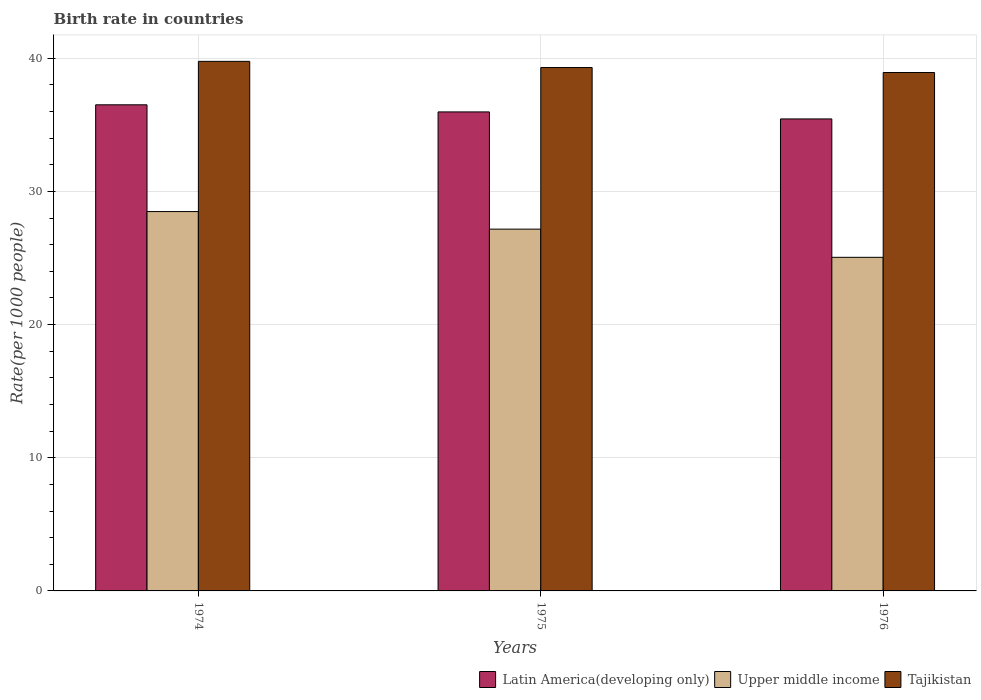How many groups of bars are there?
Provide a succinct answer. 3. Are the number of bars per tick equal to the number of legend labels?
Give a very brief answer. Yes. How many bars are there on the 3rd tick from the right?
Offer a terse response. 3. What is the label of the 1st group of bars from the left?
Your answer should be very brief. 1974. What is the birth rate in Upper middle income in 1976?
Give a very brief answer. 25.05. Across all years, what is the maximum birth rate in Upper middle income?
Make the answer very short. 28.49. Across all years, what is the minimum birth rate in Latin America(developing only)?
Make the answer very short. 35.45. In which year was the birth rate in Latin America(developing only) maximum?
Keep it short and to the point. 1974. In which year was the birth rate in Tajikistan minimum?
Offer a terse response. 1976. What is the total birth rate in Upper middle income in the graph?
Keep it short and to the point. 80.71. What is the difference between the birth rate in Latin America(developing only) in 1975 and that in 1976?
Offer a terse response. 0.53. What is the difference between the birth rate in Latin America(developing only) in 1975 and the birth rate in Upper middle income in 1974?
Your response must be concise. 7.48. What is the average birth rate in Tajikistan per year?
Keep it short and to the point. 39.34. In the year 1974, what is the difference between the birth rate in Tajikistan and birth rate in Upper middle income?
Your response must be concise. 11.28. What is the ratio of the birth rate in Upper middle income in 1975 to that in 1976?
Offer a very short reply. 1.08. Is the birth rate in Latin America(developing only) in 1974 less than that in 1975?
Offer a very short reply. No. Is the difference between the birth rate in Tajikistan in 1975 and 1976 greater than the difference between the birth rate in Upper middle income in 1975 and 1976?
Your response must be concise. No. What is the difference between the highest and the second highest birth rate in Latin America(developing only)?
Make the answer very short. 0.53. What is the difference between the highest and the lowest birth rate in Tajikistan?
Your response must be concise. 0.84. Is the sum of the birth rate in Upper middle income in 1974 and 1976 greater than the maximum birth rate in Tajikistan across all years?
Offer a very short reply. Yes. What does the 2nd bar from the left in 1976 represents?
Your answer should be compact. Upper middle income. What does the 2nd bar from the right in 1975 represents?
Provide a short and direct response. Upper middle income. Is it the case that in every year, the sum of the birth rate in Latin America(developing only) and birth rate in Upper middle income is greater than the birth rate in Tajikistan?
Give a very brief answer. Yes. How many bars are there?
Your response must be concise. 9. Are all the bars in the graph horizontal?
Give a very brief answer. No. How many years are there in the graph?
Make the answer very short. 3. Does the graph contain grids?
Give a very brief answer. Yes. How many legend labels are there?
Keep it short and to the point. 3. How are the legend labels stacked?
Offer a very short reply. Horizontal. What is the title of the graph?
Provide a short and direct response. Birth rate in countries. What is the label or title of the Y-axis?
Make the answer very short. Rate(per 1000 people). What is the Rate(per 1000 people) in Latin America(developing only) in 1974?
Your response must be concise. 36.51. What is the Rate(per 1000 people) of Upper middle income in 1974?
Offer a very short reply. 28.49. What is the Rate(per 1000 people) in Tajikistan in 1974?
Provide a succinct answer. 39.77. What is the Rate(per 1000 people) in Latin America(developing only) in 1975?
Offer a very short reply. 35.97. What is the Rate(per 1000 people) of Upper middle income in 1975?
Offer a terse response. 27.17. What is the Rate(per 1000 people) in Tajikistan in 1975?
Your response must be concise. 39.3. What is the Rate(per 1000 people) in Latin America(developing only) in 1976?
Ensure brevity in your answer.  35.45. What is the Rate(per 1000 people) of Upper middle income in 1976?
Offer a very short reply. 25.05. What is the Rate(per 1000 people) in Tajikistan in 1976?
Offer a terse response. 38.93. Across all years, what is the maximum Rate(per 1000 people) in Latin America(developing only)?
Make the answer very short. 36.51. Across all years, what is the maximum Rate(per 1000 people) of Upper middle income?
Give a very brief answer. 28.49. Across all years, what is the maximum Rate(per 1000 people) in Tajikistan?
Offer a very short reply. 39.77. Across all years, what is the minimum Rate(per 1000 people) of Latin America(developing only)?
Your answer should be compact. 35.45. Across all years, what is the minimum Rate(per 1000 people) in Upper middle income?
Provide a succinct answer. 25.05. Across all years, what is the minimum Rate(per 1000 people) of Tajikistan?
Give a very brief answer. 38.93. What is the total Rate(per 1000 people) of Latin America(developing only) in the graph?
Give a very brief answer. 107.93. What is the total Rate(per 1000 people) of Upper middle income in the graph?
Provide a succinct answer. 80.71. What is the total Rate(per 1000 people) in Tajikistan in the graph?
Your answer should be very brief. 118.01. What is the difference between the Rate(per 1000 people) of Latin America(developing only) in 1974 and that in 1975?
Provide a succinct answer. 0.53. What is the difference between the Rate(per 1000 people) of Upper middle income in 1974 and that in 1975?
Offer a terse response. 1.32. What is the difference between the Rate(per 1000 people) in Tajikistan in 1974 and that in 1975?
Your response must be concise. 0.47. What is the difference between the Rate(per 1000 people) in Latin America(developing only) in 1974 and that in 1976?
Keep it short and to the point. 1.06. What is the difference between the Rate(per 1000 people) of Upper middle income in 1974 and that in 1976?
Offer a terse response. 3.44. What is the difference between the Rate(per 1000 people) in Tajikistan in 1974 and that in 1976?
Keep it short and to the point. 0.84. What is the difference between the Rate(per 1000 people) in Latin America(developing only) in 1975 and that in 1976?
Provide a succinct answer. 0.53. What is the difference between the Rate(per 1000 people) of Upper middle income in 1975 and that in 1976?
Offer a terse response. 2.12. What is the difference between the Rate(per 1000 people) in Tajikistan in 1975 and that in 1976?
Your answer should be very brief. 0.37. What is the difference between the Rate(per 1000 people) in Latin America(developing only) in 1974 and the Rate(per 1000 people) in Upper middle income in 1975?
Provide a short and direct response. 9.34. What is the difference between the Rate(per 1000 people) of Latin America(developing only) in 1974 and the Rate(per 1000 people) of Tajikistan in 1975?
Your response must be concise. -2.8. What is the difference between the Rate(per 1000 people) of Upper middle income in 1974 and the Rate(per 1000 people) of Tajikistan in 1975?
Make the answer very short. -10.82. What is the difference between the Rate(per 1000 people) in Latin America(developing only) in 1974 and the Rate(per 1000 people) in Upper middle income in 1976?
Provide a short and direct response. 11.45. What is the difference between the Rate(per 1000 people) of Latin America(developing only) in 1974 and the Rate(per 1000 people) of Tajikistan in 1976?
Your response must be concise. -2.42. What is the difference between the Rate(per 1000 people) of Upper middle income in 1974 and the Rate(per 1000 people) of Tajikistan in 1976?
Offer a terse response. -10.44. What is the difference between the Rate(per 1000 people) of Latin America(developing only) in 1975 and the Rate(per 1000 people) of Upper middle income in 1976?
Give a very brief answer. 10.92. What is the difference between the Rate(per 1000 people) of Latin America(developing only) in 1975 and the Rate(per 1000 people) of Tajikistan in 1976?
Make the answer very short. -2.96. What is the difference between the Rate(per 1000 people) in Upper middle income in 1975 and the Rate(per 1000 people) in Tajikistan in 1976?
Provide a short and direct response. -11.76. What is the average Rate(per 1000 people) of Latin America(developing only) per year?
Provide a succinct answer. 35.98. What is the average Rate(per 1000 people) in Upper middle income per year?
Provide a succinct answer. 26.9. What is the average Rate(per 1000 people) of Tajikistan per year?
Provide a succinct answer. 39.34. In the year 1974, what is the difference between the Rate(per 1000 people) of Latin America(developing only) and Rate(per 1000 people) of Upper middle income?
Your answer should be very brief. 8.02. In the year 1974, what is the difference between the Rate(per 1000 people) of Latin America(developing only) and Rate(per 1000 people) of Tajikistan?
Your answer should be very brief. -3.26. In the year 1974, what is the difference between the Rate(per 1000 people) in Upper middle income and Rate(per 1000 people) in Tajikistan?
Keep it short and to the point. -11.28. In the year 1975, what is the difference between the Rate(per 1000 people) of Latin America(developing only) and Rate(per 1000 people) of Upper middle income?
Give a very brief answer. 8.8. In the year 1975, what is the difference between the Rate(per 1000 people) in Latin America(developing only) and Rate(per 1000 people) in Tajikistan?
Offer a terse response. -3.33. In the year 1975, what is the difference between the Rate(per 1000 people) of Upper middle income and Rate(per 1000 people) of Tajikistan?
Ensure brevity in your answer.  -12.14. In the year 1976, what is the difference between the Rate(per 1000 people) of Latin America(developing only) and Rate(per 1000 people) of Upper middle income?
Offer a very short reply. 10.39. In the year 1976, what is the difference between the Rate(per 1000 people) in Latin America(developing only) and Rate(per 1000 people) in Tajikistan?
Your answer should be compact. -3.48. In the year 1976, what is the difference between the Rate(per 1000 people) of Upper middle income and Rate(per 1000 people) of Tajikistan?
Your answer should be very brief. -13.88. What is the ratio of the Rate(per 1000 people) in Latin America(developing only) in 1974 to that in 1975?
Offer a terse response. 1.01. What is the ratio of the Rate(per 1000 people) of Upper middle income in 1974 to that in 1975?
Provide a short and direct response. 1.05. What is the ratio of the Rate(per 1000 people) in Tajikistan in 1974 to that in 1975?
Keep it short and to the point. 1.01. What is the ratio of the Rate(per 1000 people) in Latin America(developing only) in 1974 to that in 1976?
Give a very brief answer. 1.03. What is the ratio of the Rate(per 1000 people) of Upper middle income in 1974 to that in 1976?
Your response must be concise. 1.14. What is the ratio of the Rate(per 1000 people) in Tajikistan in 1974 to that in 1976?
Keep it short and to the point. 1.02. What is the ratio of the Rate(per 1000 people) of Latin America(developing only) in 1975 to that in 1976?
Ensure brevity in your answer.  1.01. What is the ratio of the Rate(per 1000 people) in Upper middle income in 1975 to that in 1976?
Keep it short and to the point. 1.08. What is the ratio of the Rate(per 1000 people) in Tajikistan in 1975 to that in 1976?
Your answer should be very brief. 1.01. What is the difference between the highest and the second highest Rate(per 1000 people) in Latin America(developing only)?
Your response must be concise. 0.53. What is the difference between the highest and the second highest Rate(per 1000 people) in Upper middle income?
Ensure brevity in your answer.  1.32. What is the difference between the highest and the second highest Rate(per 1000 people) of Tajikistan?
Your answer should be compact. 0.47. What is the difference between the highest and the lowest Rate(per 1000 people) in Latin America(developing only)?
Provide a succinct answer. 1.06. What is the difference between the highest and the lowest Rate(per 1000 people) in Upper middle income?
Your answer should be compact. 3.44. What is the difference between the highest and the lowest Rate(per 1000 people) in Tajikistan?
Your answer should be very brief. 0.84. 